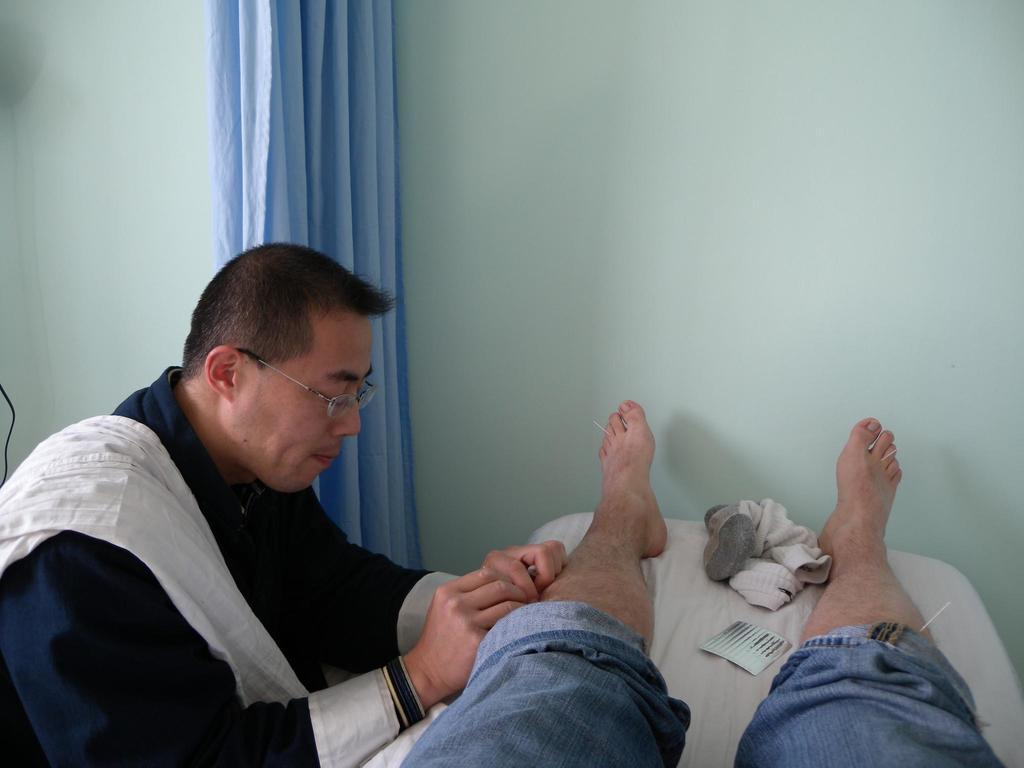What is the position of the person in the image? There is a person lying on the bed in the image. What is the other person in the image doing? There is another person sitting on a chair in the image. Can you describe any specific features of the room in the image? There is a blue curtain in the image. What type of lumber is being used to construct the bed in the image? There is no information about the construction of the bed in the image, and no lumber is visible. 